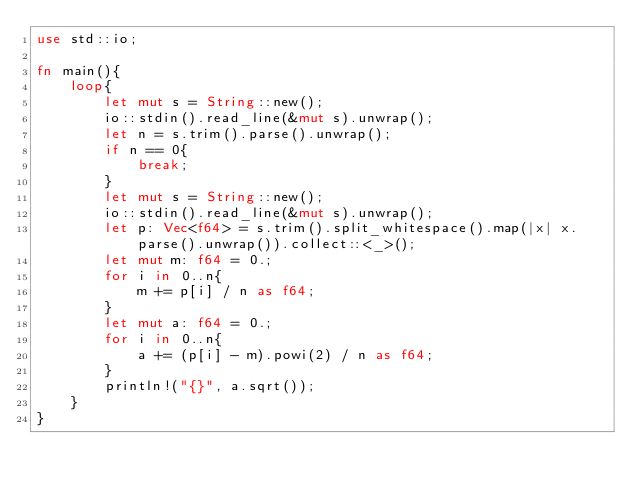Convert code to text. <code><loc_0><loc_0><loc_500><loc_500><_Rust_>use std::io;

fn main(){
    loop{
        let mut s = String::new();
        io::stdin().read_line(&mut s).unwrap();
        let n = s.trim().parse().unwrap();
        if n == 0{
            break;
        }
        let mut s = String::new();
        io::stdin().read_line(&mut s).unwrap();
        let p: Vec<f64> = s.trim().split_whitespace().map(|x| x.parse().unwrap()).collect::<_>();
        let mut m: f64 = 0.;
        for i in 0..n{
            m += p[i] / n as f64;
        }
        let mut a: f64 = 0.;
        for i in 0..n{
            a += (p[i] - m).powi(2) / n as f64;
        }
        println!("{}", a.sqrt());
    }
}
</code> 